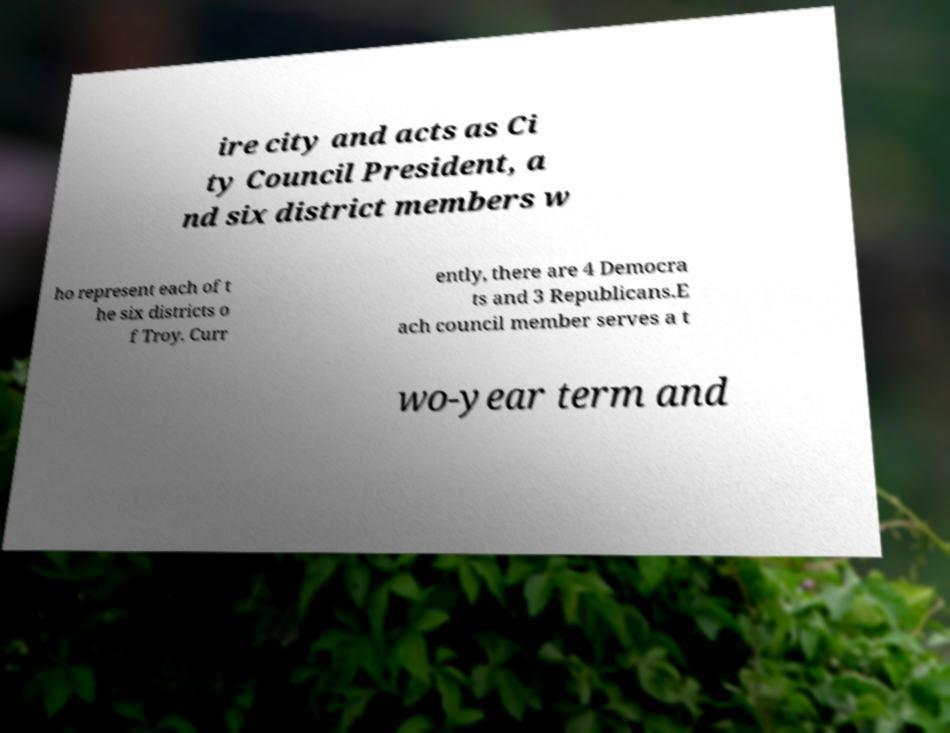Can you read and provide the text displayed in the image?This photo seems to have some interesting text. Can you extract and type it out for me? ire city and acts as Ci ty Council President, a nd six district members w ho represent each of t he six districts o f Troy. Curr ently, there are 4 Democra ts and 3 Republicans.E ach council member serves a t wo-year term and 